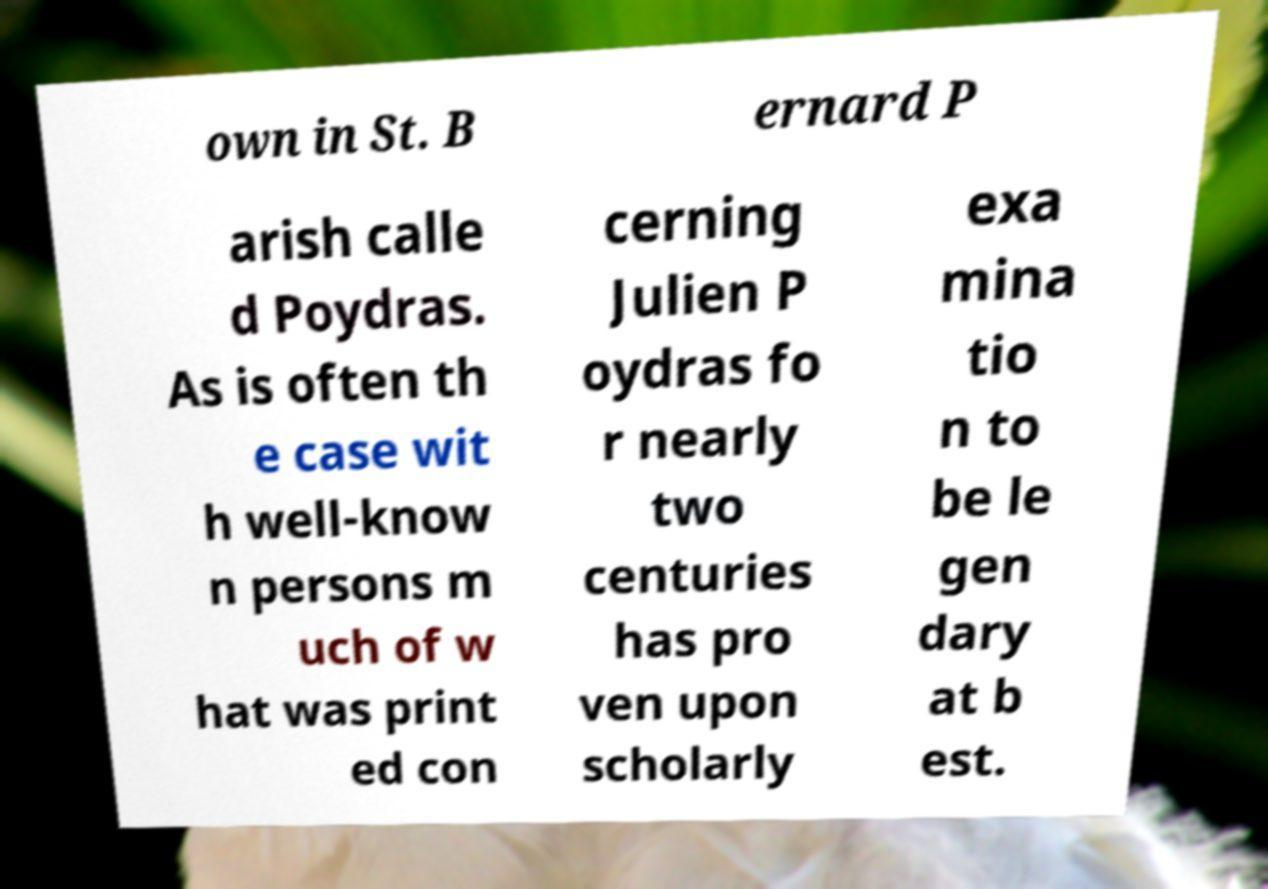For documentation purposes, I need the text within this image transcribed. Could you provide that? own in St. B ernard P arish calle d Poydras. As is often th e case wit h well-know n persons m uch of w hat was print ed con cerning Julien P oydras fo r nearly two centuries has pro ven upon scholarly exa mina tio n to be le gen dary at b est. 